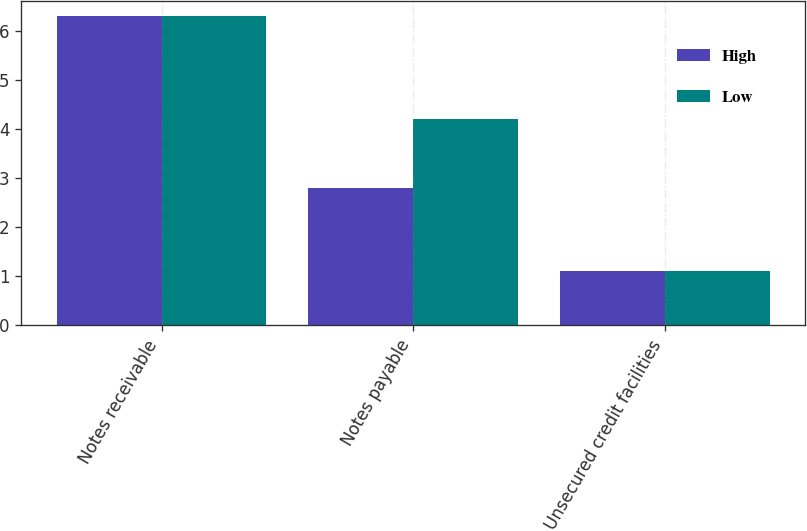Convert chart. <chart><loc_0><loc_0><loc_500><loc_500><stacked_bar_chart><ecel><fcel>Notes receivable<fcel>Notes payable<fcel>Unsecured credit facilities<nl><fcel>High<fcel>6.3<fcel>2.8<fcel>1.1<nl><fcel>Low<fcel>6.3<fcel>4.2<fcel>1.1<nl></chart> 